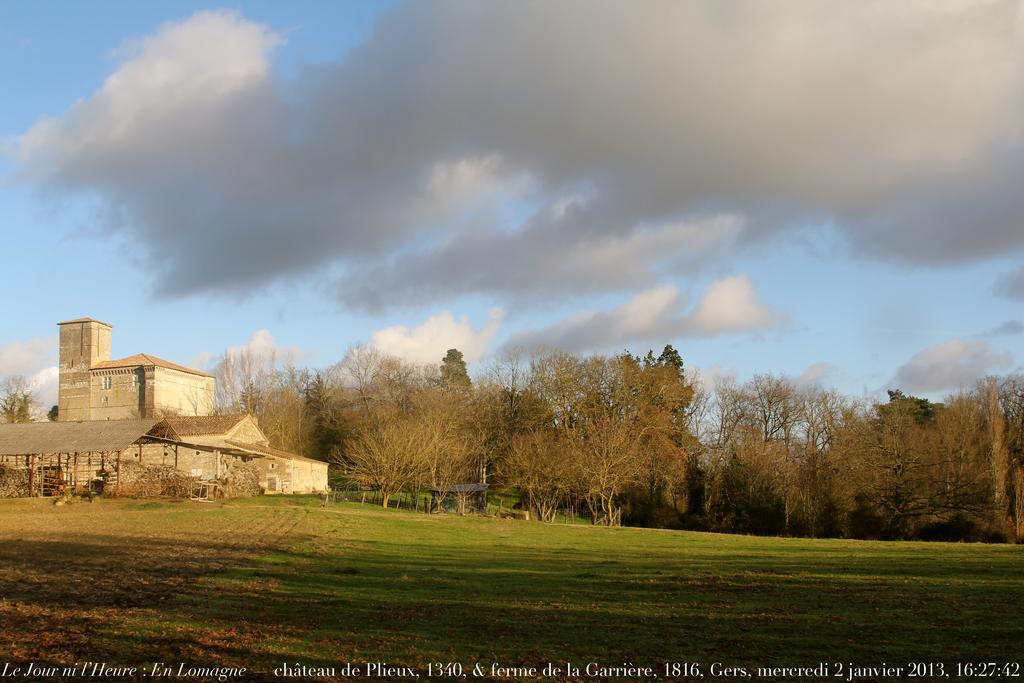What type of structure is present in the image? There is a building in the image. What other type of structure can be seen in the image? There is a shelter in the image. What natural elements are present in the image? There are trees and grass in the image. What can be seen in the background of the image? The sky is visible in the background of the image, and there are clouds in the sky. How many cherries are hanging from the trees in the image? There are no cherries present in the image. What is the condition of the throat of the person in the image? There is no person present in the image. 